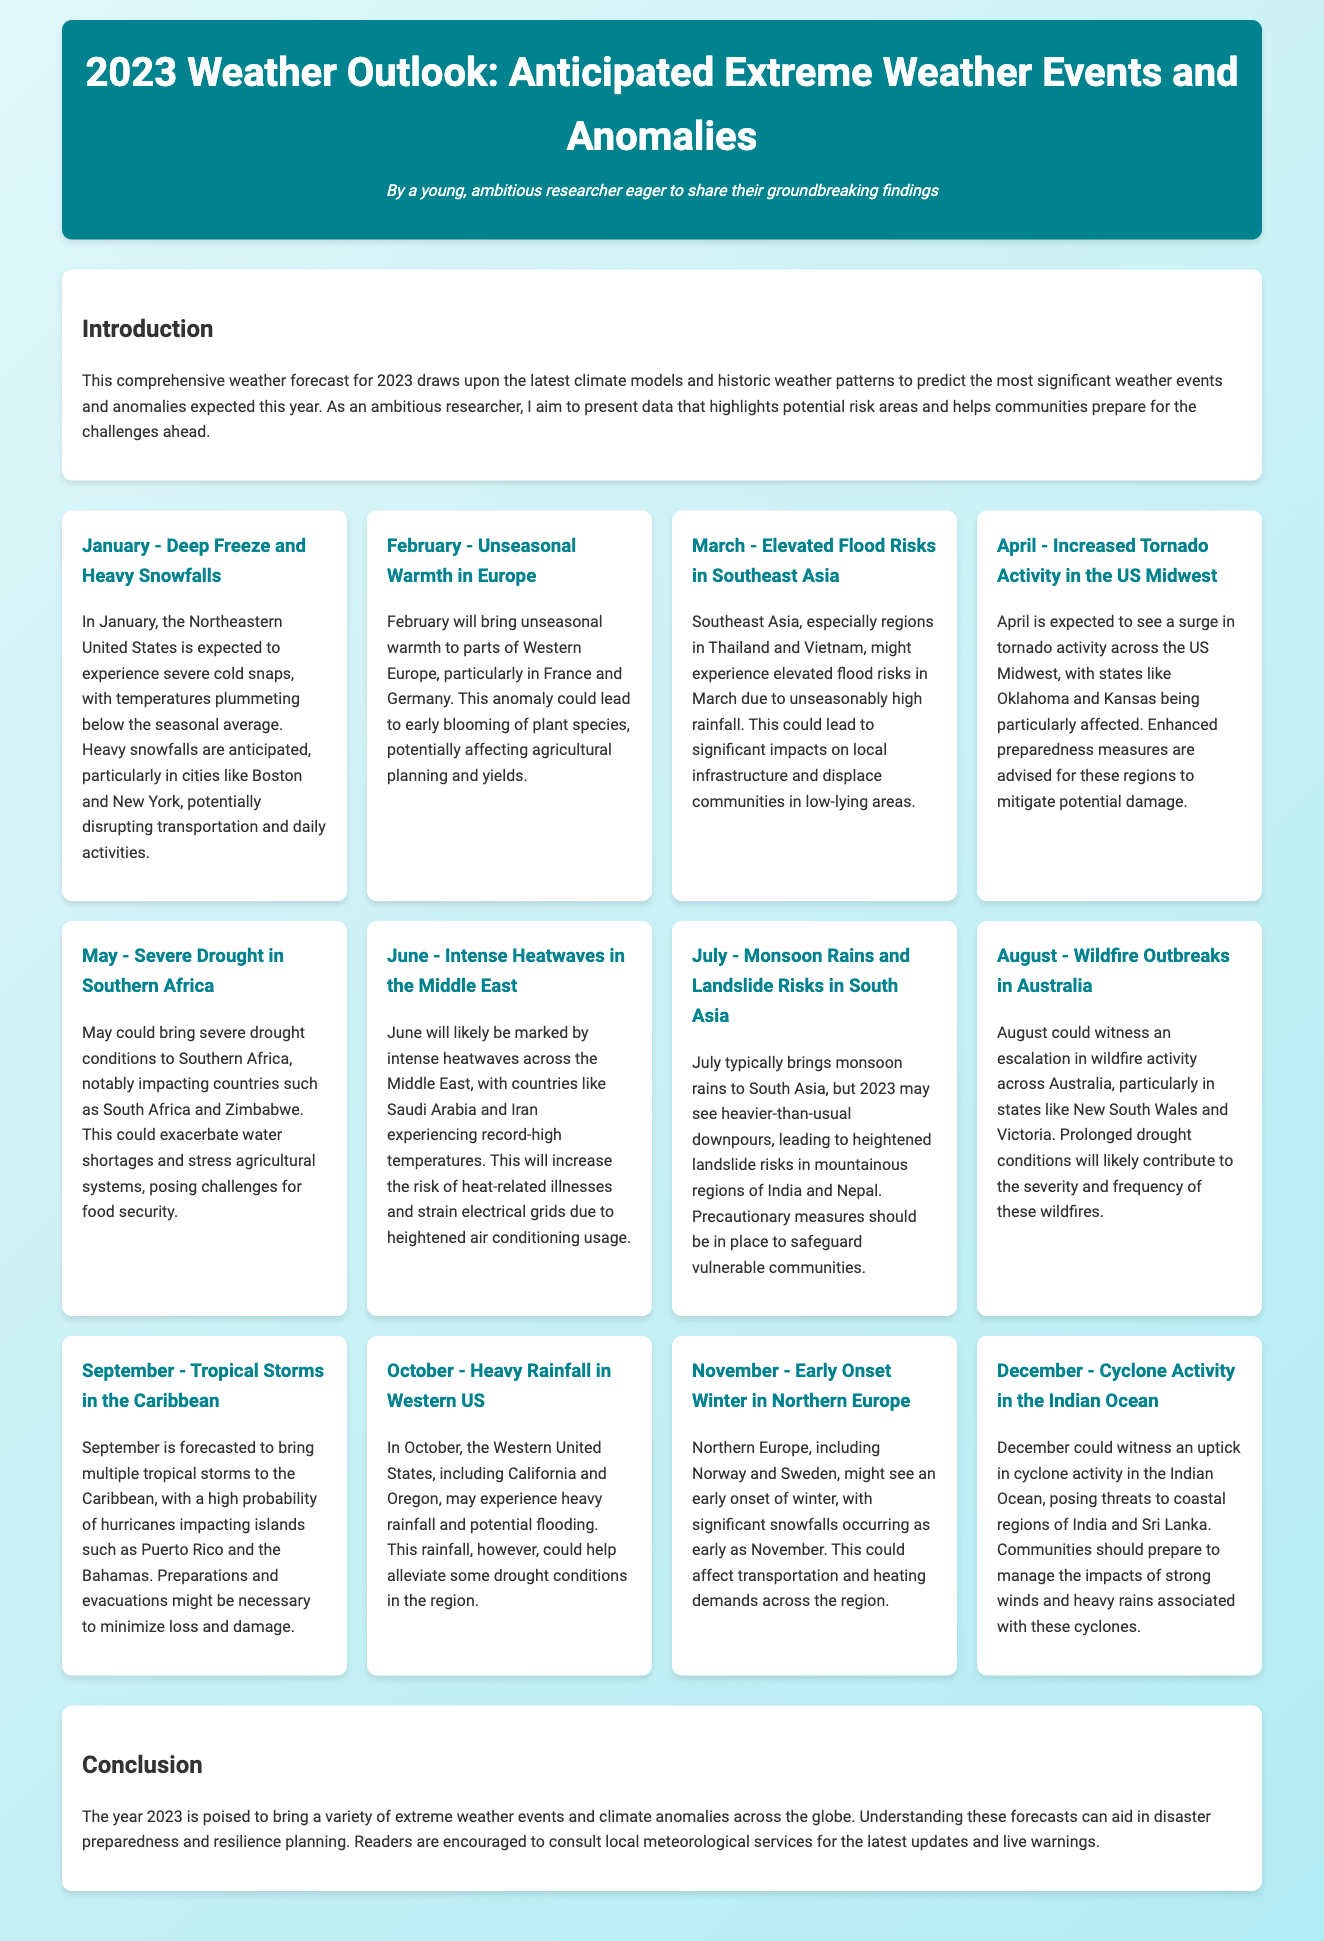What severe weather is expected in January? January is expected to experience severe cold snaps and heavy snowfalls in the Northeastern United States.
Answer: Deep Freeze and Heavy Snowfalls What month is predicted to have unseasonal warmth? February is forecasted to bring unseasonal warmth to parts of Western Europe.
Answer: February Which region faces elevated flood risks in March? Southeast Asia, particularly regions in Thailand and Vietnam, faces elevated flood risks in March.
Answer: Southeast Asia What extreme weather events are anticipated in July? July is predicted to have monsoon rains and heightened landslide risks in mountainous regions of India and Nepal.
Answer: Monsoon Rains and Landslide Risks In what month is cyclone activity expected to increase? Cyclone activity is expected to increase in December in the Indian Ocean.
Answer: December What is a notable weather anomaly in February? February will bring unseasonal warmth, affecting agricultural planning and yields.
Answer: Unseasonal Warmth How might October's rainfall impact drought conditions? The heavy rainfall in October could help alleviate some drought conditions.
Answer: Alleviate drought conditions What geographical area is expected to experience intense heatwaves in June? The Middle East, particularly countries like Saudi Arabia and Iran, is anticipated to experience intense heatwaves.
Answer: Middle East What potential challenges could arise from the weather in May? Severe drought conditions in Southern Africa could exacerbate water shortages and stress agricultural systems.
Answer: Water shortages and agricultural stress 